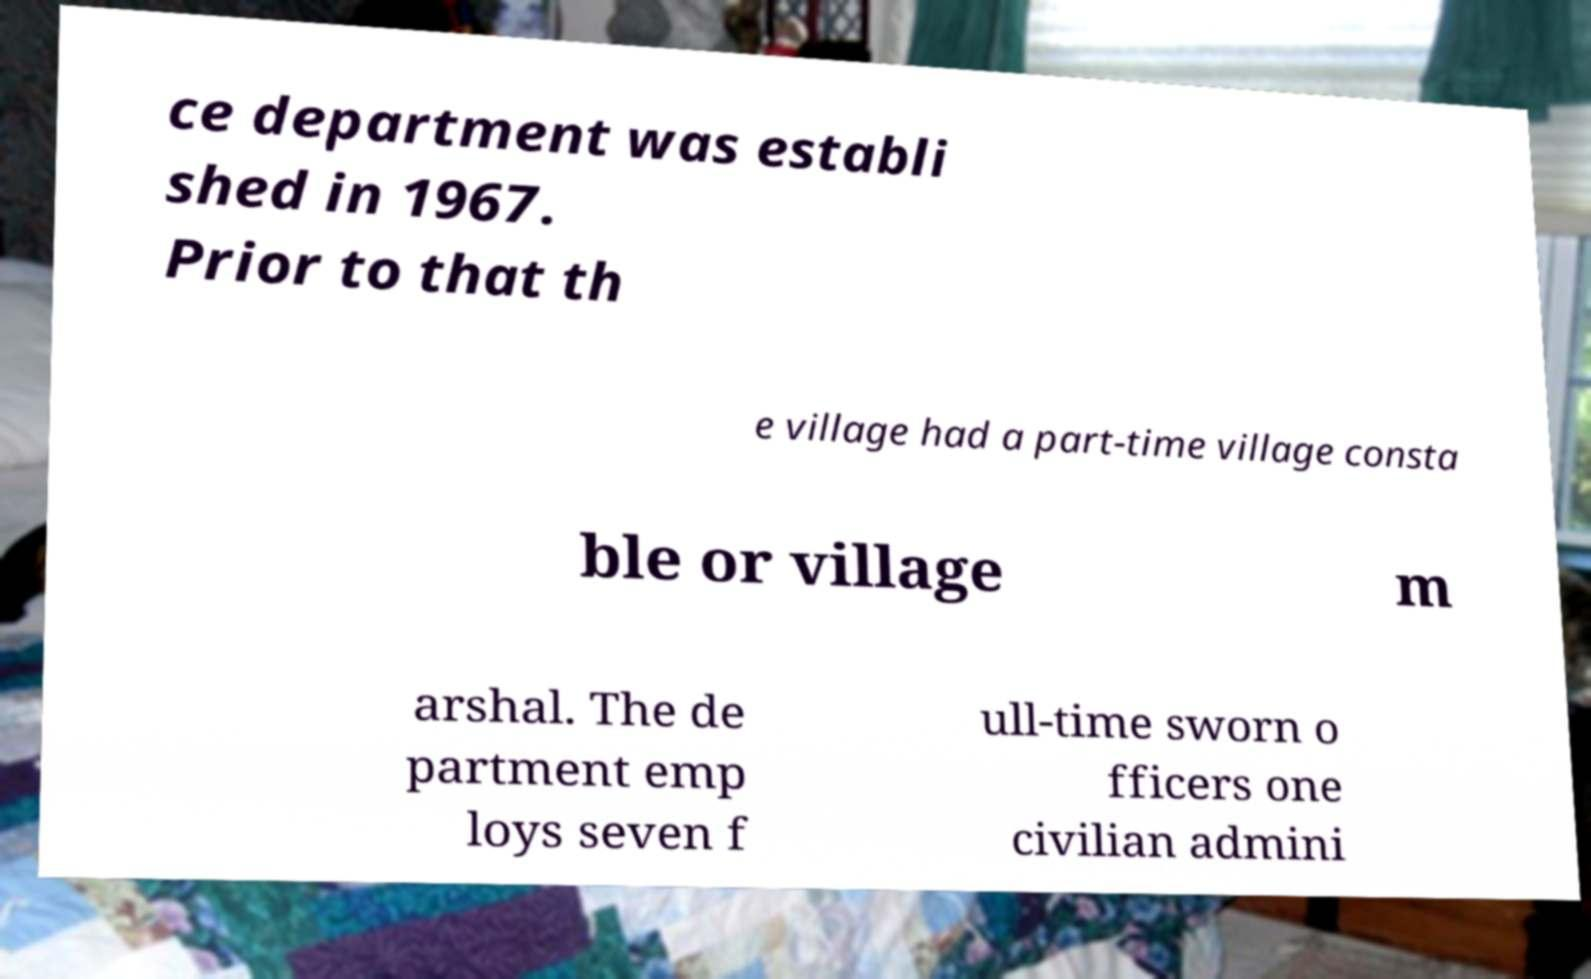What messages or text are displayed in this image? I need them in a readable, typed format. ce department was establi shed in 1967. Prior to that th e village had a part-time village consta ble or village m arshal. The de partment emp loys seven f ull-time sworn o fficers one civilian admini 